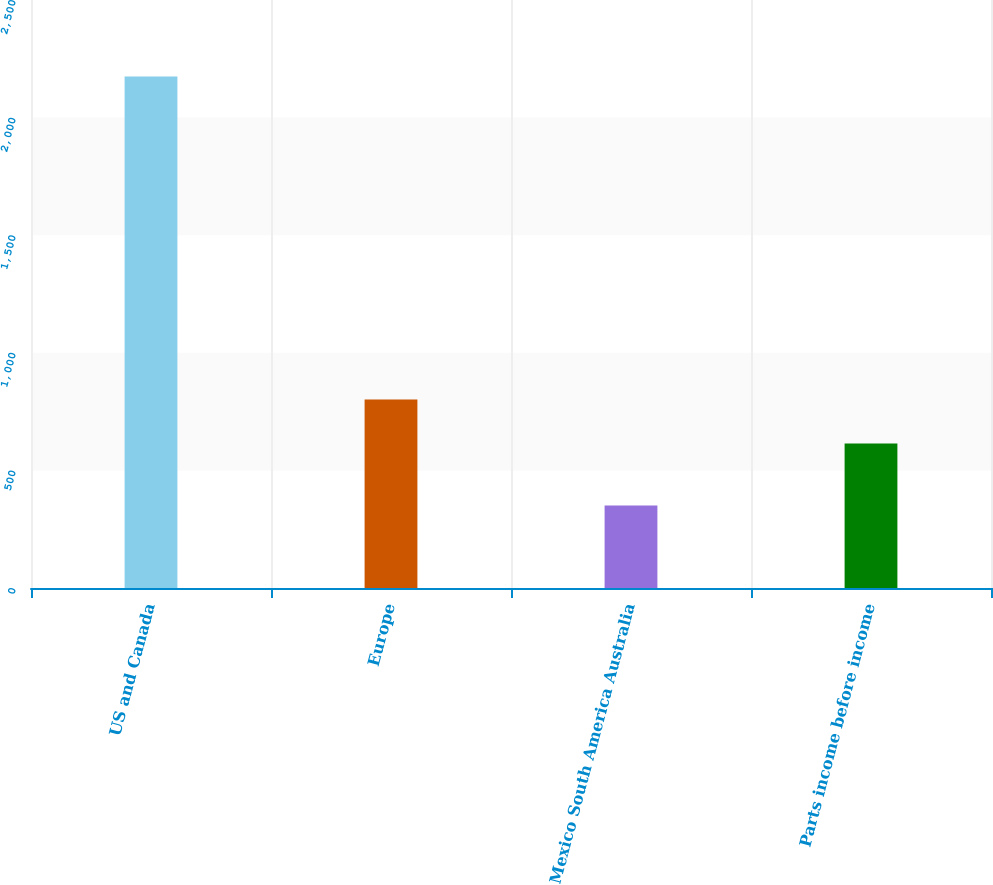<chart> <loc_0><loc_0><loc_500><loc_500><bar_chart><fcel>US and Canada<fcel>Europe<fcel>Mexico South America Australia<fcel>Parts income before income<nl><fcel>2175<fcel>801<fcel>351<fcel>614.2<nl></chart> 